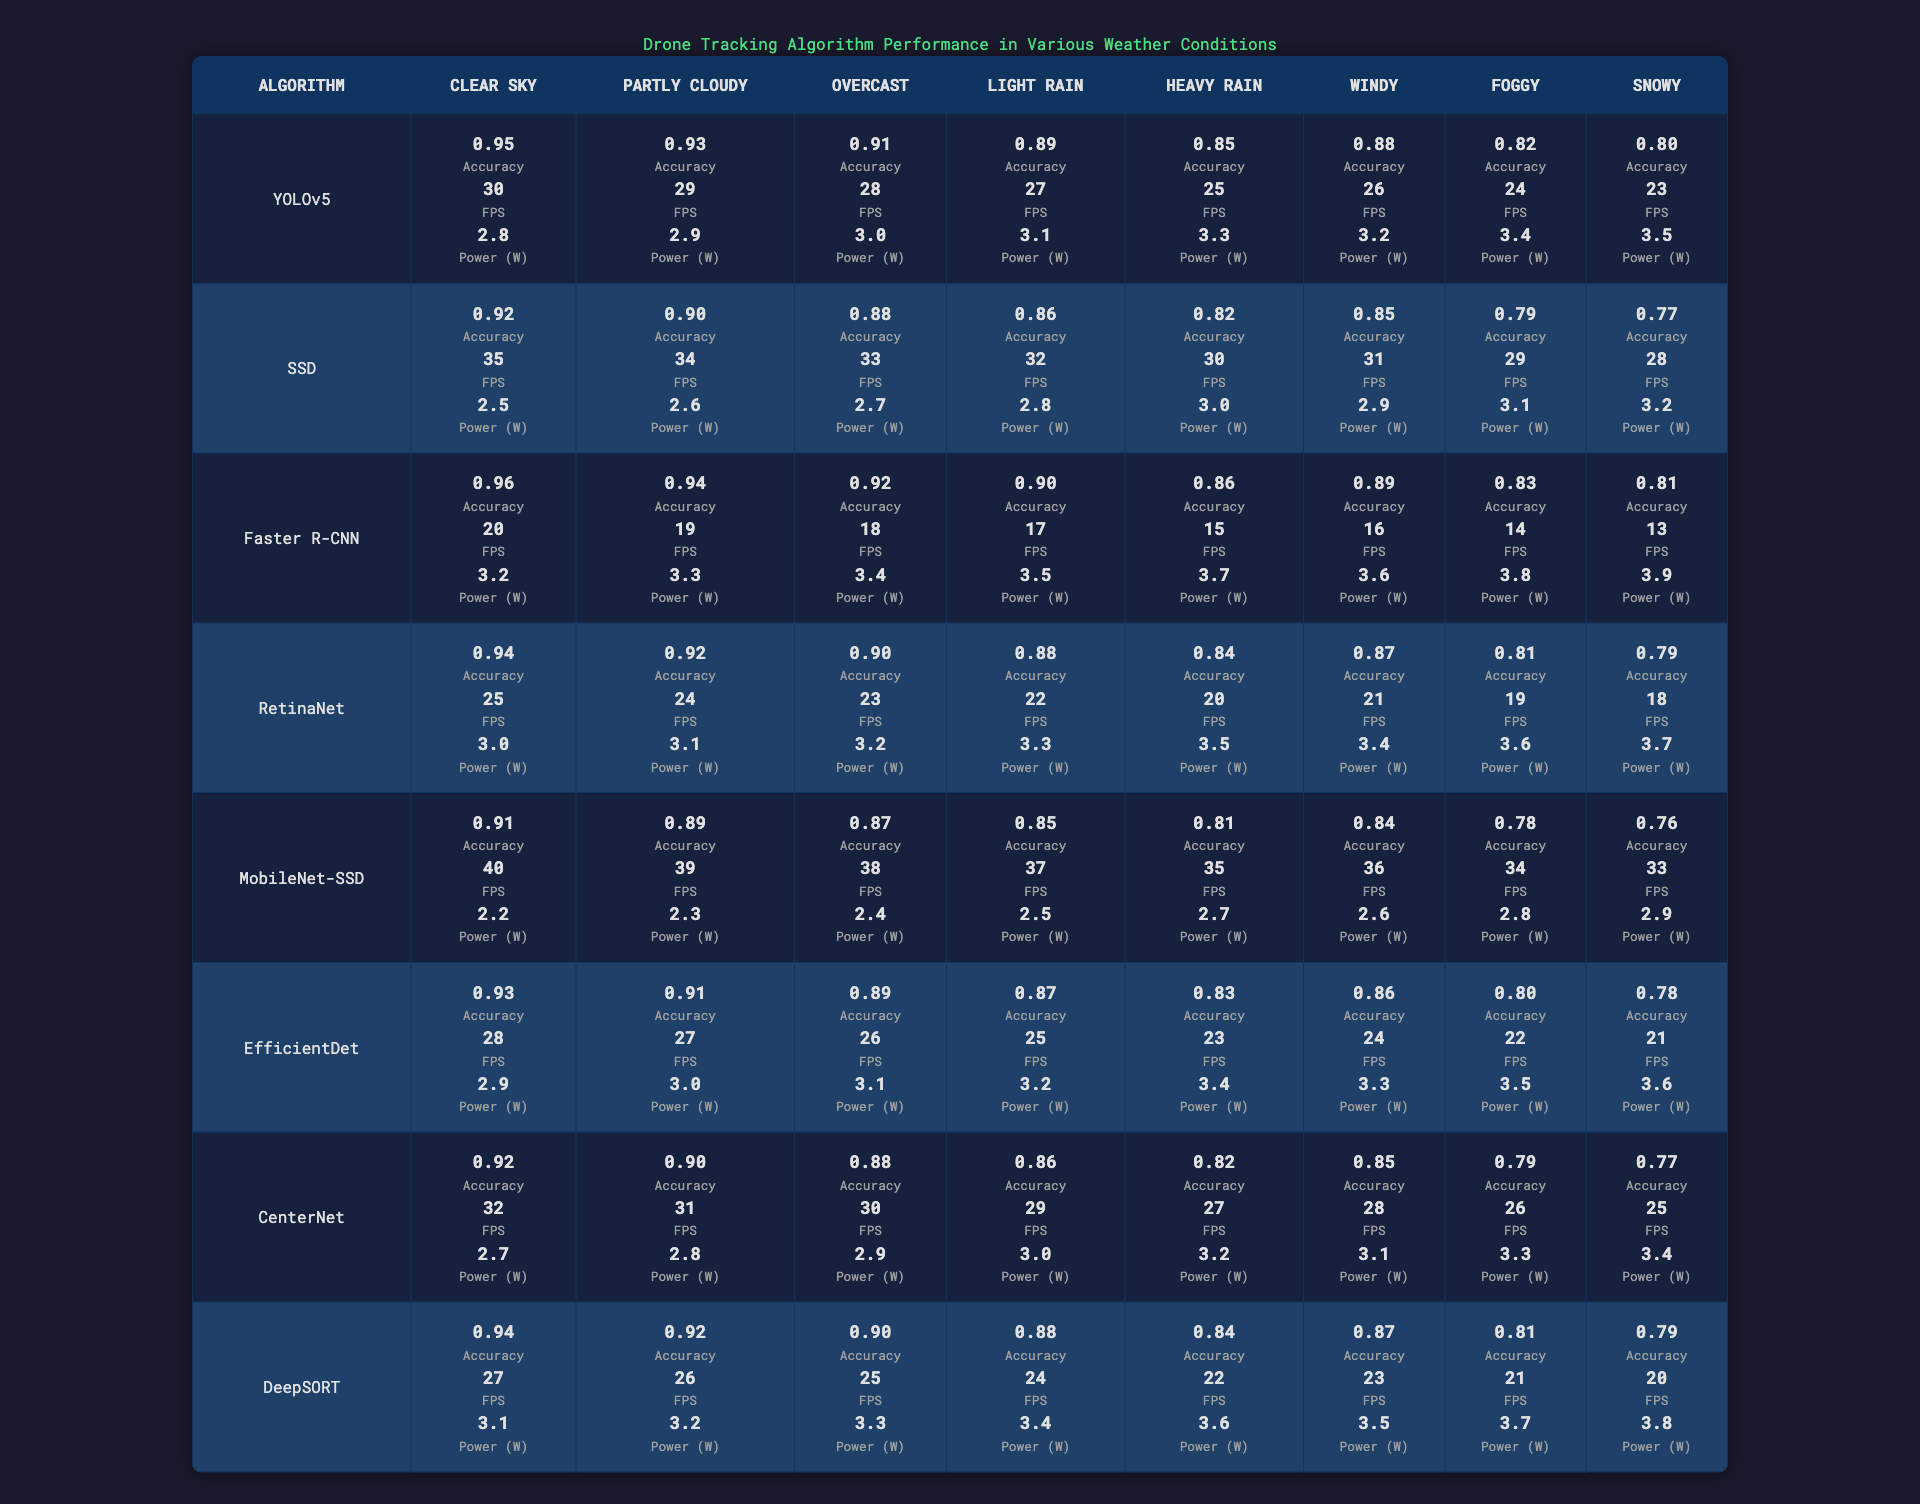What is the accuracy of YOLOv5 in clear sky conditions? The table indicates that YOLOv5 has an accuracy of 0.95 in clear sky conditions, as directly shown in the corresponding cell.
Answer: 0.95 Which algorithm has the highest FPS in snowy conditions? Looking through the table, MobileNet-SSD has the highest FPS at 33 in snowy conditions, which is evident in the relevant cell in the snowy column.
Answer: MobileNet-SSD What is the average power consumption across all algorithms in windy conditions? To find the average, we sum the power consumption values in windy conditions: (3.2 + 2.9 + 3.6 + 3.4 + 2.6 + 3.1 + 3.5 + 3.3) = 23.6. Then, divide by 8 algorithms: 23.6 / 8 = 2.95.
Answer: 2.95 Does Faster R-CNN perform better than RetinaNet in cloudy conditions in terms of accuracy? Check the accuracy values in the "Partly Cloudy" row for both algorithms. Faster R-CNN has an accuracy of 0.94, while RetinaNet has 0.92. Since 0.94 is greater than 0.92, the statement is true.
Answer: Yes Which algorithm shows the least decline in accuracy from clear sky to heavy rain conditions? To determine this, we calculate the accuracy decline for each algorithm from "Clear Sky" to "Heavy Rain". The declines are as follows:
- YOLOv5: 0.95 - 0.85 = 0.10
- SSD: 0.92 - 0.82 = 0.10
- Faster R-CNN: 0.96 - 0.86 = 0.10
- RetinaNet: 0.94 - 0.84 = 0.10
- MobileNet-SSD: 0.91 - 0.81 = 0.10
- EfficientDet: 0.93 - 0.83 = 0.10
- CenterNet: 0.92 - 0.82 = 0.10
- DeepSORT: 0.94 - 0.84 = 0.10
Since all algorithms show an equal decline of 0.10, there isn't one algorithm that performs better in this regard.
Answer: All have the same decline What is the overall power consumption trend across the algorithms as the weather worsens? The table shows that as the weather changes from clear to snowy conditions, the power consumption generally increases across all algorithms. By analyzing the values, we can observe a trend of rising power consumption as conditions worsen. Therefore, the trend is positive.
Answer: Power consumption generally increases 